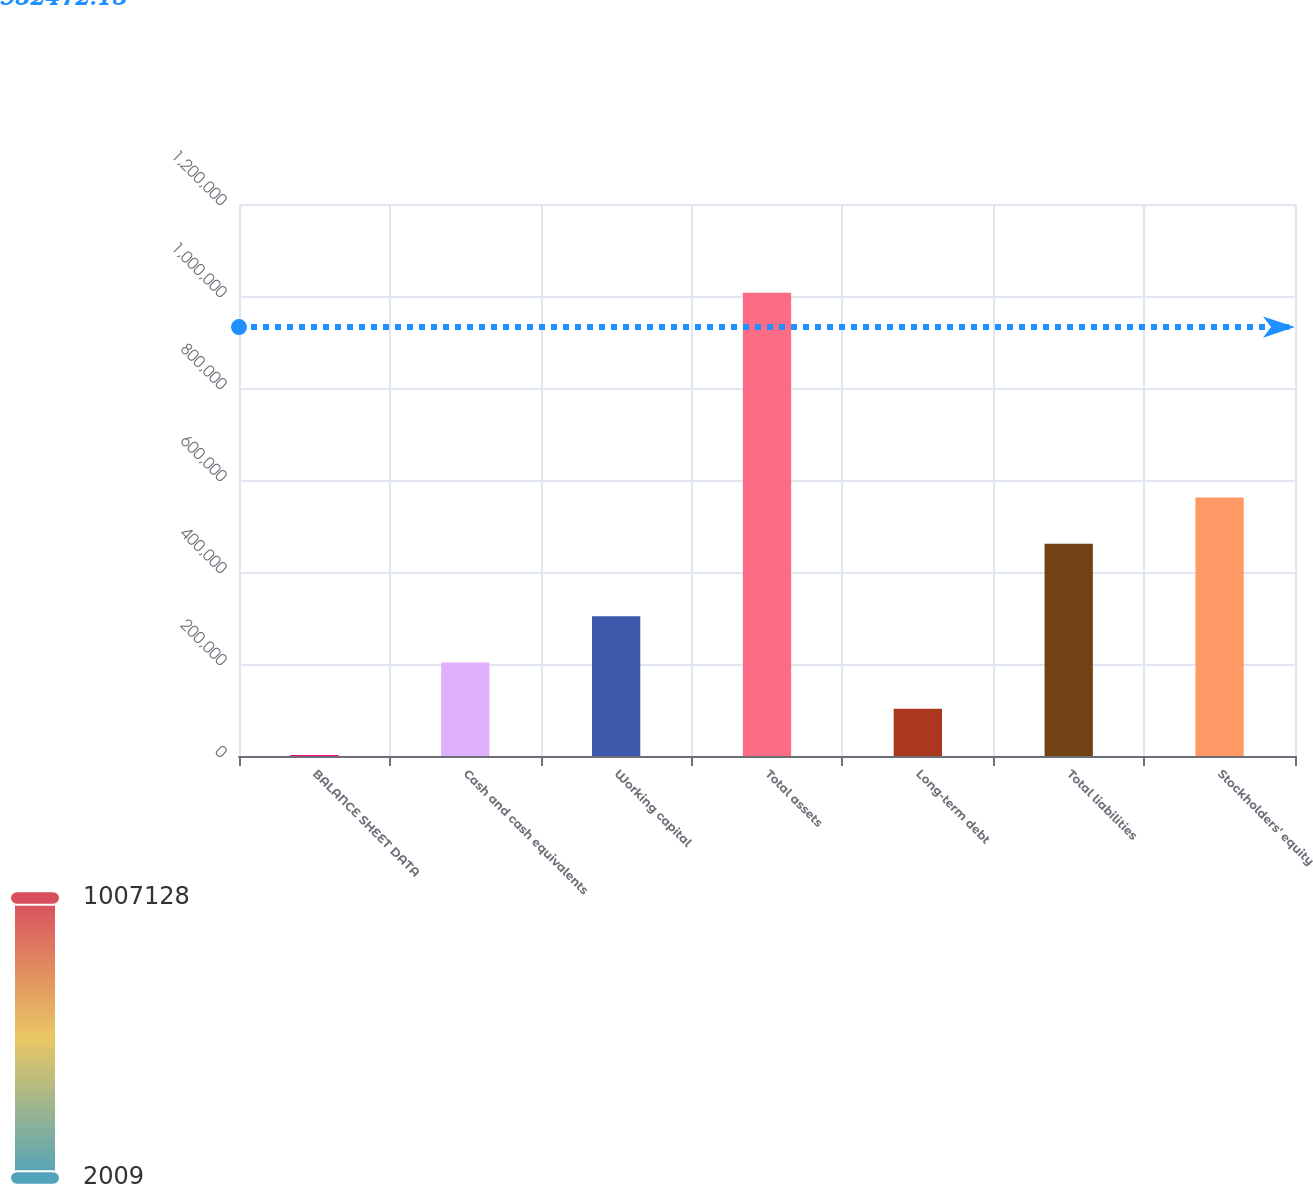<chart> <loc_0><loc_0><loc_500><loc_500><bar_chart><fcel>BALANCE SHEET DATA<fcel>Cash and cash equivalents<fcel>Working capital<fcel>Total assets<fcel>Long-term debt<fcel>Total liabilities<fcel>Stockholders' equity<nl><fcel>2009<fcel>203033<fcel>303545<fcel>1.00713e+06<fcel>102521<fcel>461502<fcel>562014<nl></chart> 